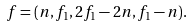Convert formula to latex. <formula><loc_0><loc_0><loc_500><loc_500>f = ( n , f _ { 1 } , 2 f _ { 1 } - 2 n , f _ { 1 } - n ) .</formula> 